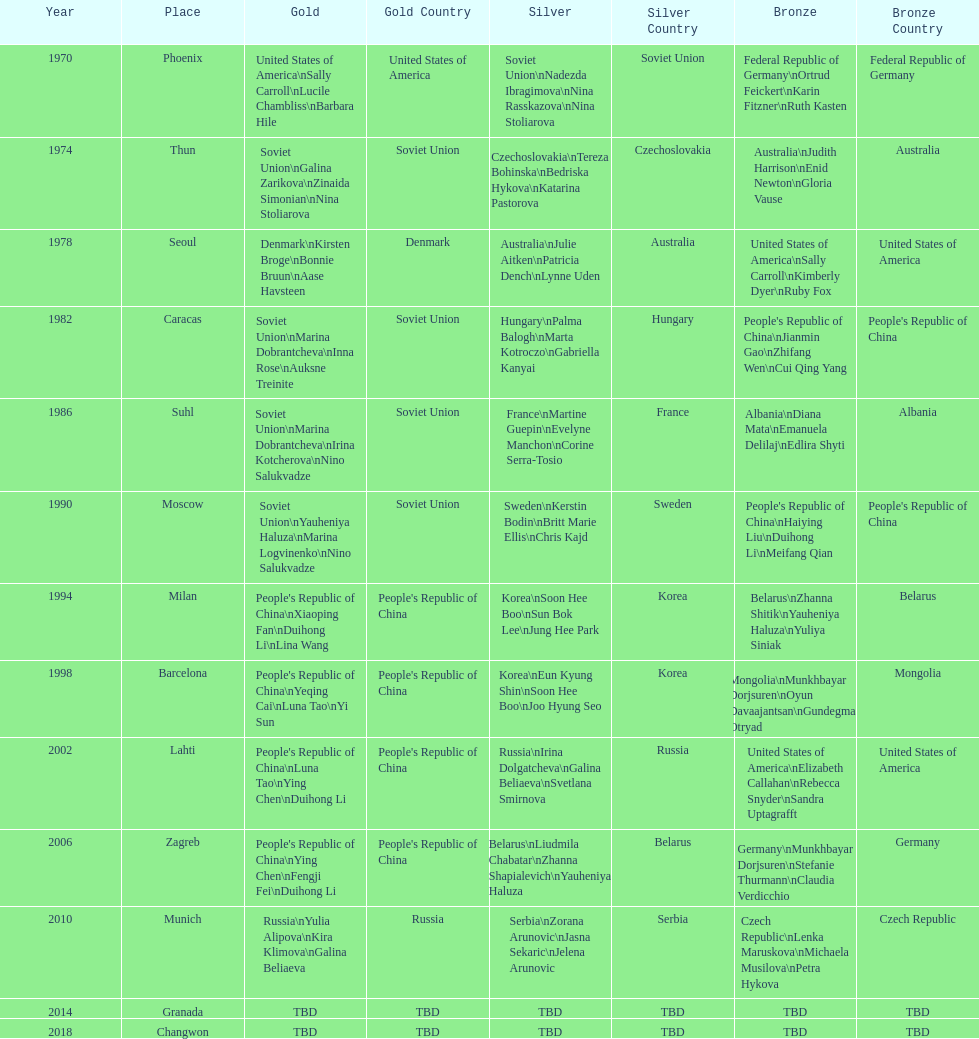Would you mind parsing the complete table? {'header': ['Year', 'Place', 'Gold', 'Gold Country', 'Silver', 'Silver Country', 'Bronze', 'Bronze Country'], 'rows': [['1970', 'Phoenix', 'United States of America\\nSally Carroll\\nLucile Chambliss\\nBarbara Hile', 'United States of America', 'Soviet Union\\nNadezda Ibragimova\\nNina Rasskazova\\nNina Stoliarova', 'Soviet Union', 'Federal Republic of Germany\\nOrtrud Feickert\\nKarin Fitzner\\nRuth Kasten', 'Federal Republic of Germany'], ['1974', 'Thun', 'Soviet Union\\nGalina Zarikova\\nZinaida Simonian\\nNina Stoliarova', 'Soviet Union', 'Czechoslovakia\\nTereza Bohinska\\nBedriska Hykova\\nKatarina Pastorova', 'Czechoslovakia', 'Australia\\nJudith Harrison\\nEnid Newton\\nGloria Vause', 'Australia'], ['1978', 'Seoul', 'Denmark\\nKirsten Broge\\nBonnie Bruun\\nAase Havsteen', 'Denmark', 'Australia\\nJulie Aitken\\nPatricia Dench\\nLynne Uden', 'Australia', 'United States of America\\nSally Carroll\\nKimberly Dyer\\nRuby Fox', 'United States of America'], ['1982', 'Caracas', 'Soviet Union\\nMarina Dobrantcheva\\nInna Rose\\nAuksne Treinite', 'Soviet Union', 'Hungary\\nPalma Balogh\\nMarta Kotroczo\\nGabriella Kanyai', 'Hungary', "People's Republic of China\\nJianmin Gao\\nZhifang Wen\\nCui Qing Yang", "People's Republic of China"], ['1986', 'Suhl', 'Soviet Union\\nMarina Dobrantcheva\\nIrina Kotcherova\\nNino Salukvadze', 'Soviet Union', 'France\\nMartine Guepin\\nEvelyne Manchon\\nCorine Serra-Tosio', 'France', 'Albania\\nDiana Mata\\nEmanuela Delilaj\\nEdlira Shyti', 'Albania'], ['1990', 'Moscow', 'Soviet Union\\nYauheniya Haluza\\nMarina Logvinenko\\nNino Salukvadze', 'Soviet Union', 'Sweden\\nKerstin Bodin\\nBritt Marie Ellis\\nChris Kajd', 'Sweden', "People's Republic of China\\nHaiying Liu\\nDuihong Li\\nMeifang Qian", "People's Republic of China"], ['1994', 'Milan', "People's Republic of China\\nXiaoping Fan\\nDuihong Li\\nLina Wang", "People's Republic of China", 'Korea\\nSoon Hee Boo\\nSun Bok Lee\\nJung Hee Park', 'Korea', 'Belarus\\nZhanna Shitik\\nYauheniya Haluza\\nYuliya Siniak', 'Belarus'], ['1998', 'Barcelona', "People's Republic of China\\nYeqing Cai\\nLuna Tao\\nYi Sun", "People's Republic of China", 'Korea\\nEun Kyung Shin\\nSoon Hee Boo\\nJoo Hyung Seo', 'Korea', 'Mongolia\\nMunkhbayar Dorjsuren\\nOyun Davaajantsan\\nGundegmaa Otryad', 'Mongolia'], ['2002', 'Lahti', "People's Republic of China\\nLuna Tao\\nYing Chen\\nDuihong Li", "People's Republic of China", 'Russia\\nIrina Dolgatcheva\\nGalina Beliaeva\\nSvetlana Smirnova', 'Russia', 'United States of America\\nElizabeth Callahan\\nRebecca Snyder\\nSandra Uptagrafft', 'United States of America'], ['2006', 'Zagreb', "People's Republic of China\\nYing Chen\\nFengji Fei\\nDuihong Li", "People's Republic of China", 'Belarus\\nLiudmila Chabatar\\nZhanna Shapialevich\\nYauheniya Haluza', 'Belarus', 'Germany\\nMunkhbayar Dorjsuren\\nStefanie Thurmann\\nClaudia Verdicchio', 'Germany'], ['2010', 'Munich', 'Russia\\nYulia Alipova\\nKira Klimova\\nGalina Beliaeva', 'Russia', 'Serbia\\nZorana Arunovic\\nJasna Sekaric\\nJelena Arunovic', 'Serbia', 'Czech Republic\\nLenka Maruskova\\nMichaela Musilova\\nPetra Hykova', 'Czech Republic'], ['2014', 'Granada', 'TBD', 'TBD', 'TBD', 'TBD', 'TBD', 'TBD'], ['2018', 'Changwon', 'TBD', 'TBD', 'TBD', 'TBD', 'TBD', 'TBD']]} How many world championships had the soviet union won first place in in the 25 metre pistol women's world championship? 4. 